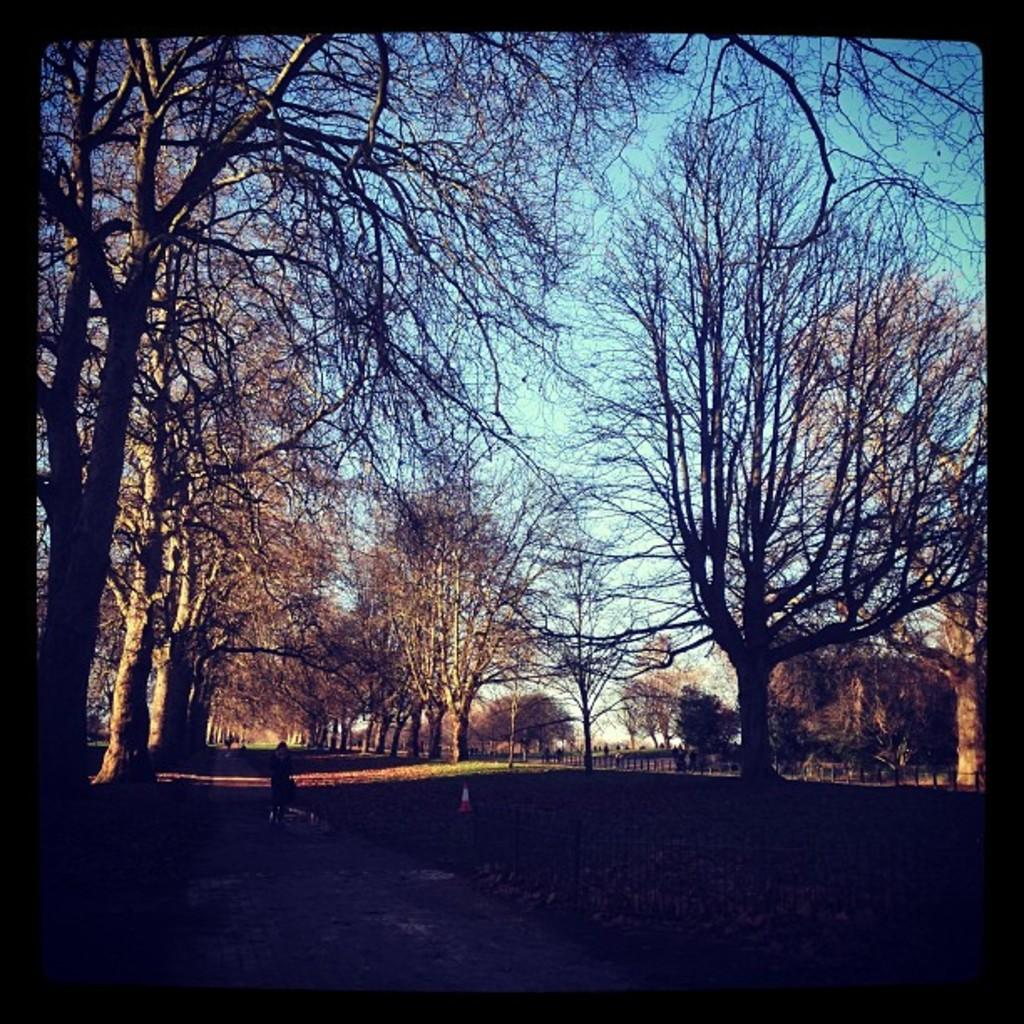What type of vegetation can be seen in the image? There is a group of trees in the image. What structure is present in the image? There is a fence in the image. What can be seen in the background of the image? The sky is visible in the background of the image. What type of observation can be made about the battle in the image? There is no battle present in the image; it features a group of trees and a fence. What is the height of the low structure in the image? There is no low structure present in the image; it features a group of trees and a fence. 